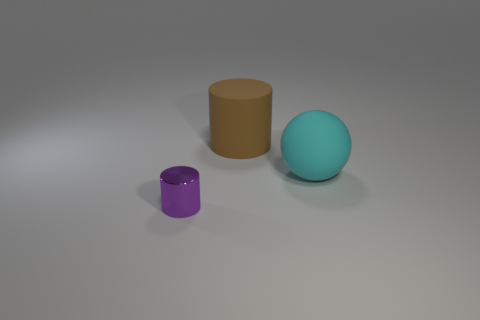Is there anything else that has the same material as the purple cylinder?
Offer a very short reply. No. There is a cylinder in front of the big cylinder; what is its material?
Make the answer very short. Metal. Is there a large thing that has the same shape as the tiny object?
Keep it short and to the point. Yes. What number of tiny green matte objects have the same shape as the tiny metallic thing?
Offer a very short reply. 0. There is a cylinder behind the small metal cylinder; is its size the same as the matte object that is in front of the brown rubber thing?
Your response must be concise. Yes. The large matte thing to the left of the object that is on the right side of the big rubber cylinder is what shape?
Offer a very short reply. Cylinder. Is the number of cylinders on the left side of the tiny object the same as the number of red matte balls?
Make the answer very short. Yes. There is a big object to the right of the cylinder that is behind the shiny cylinder that is on the left side of the large ball; what is it made of?
Give a very brief answer. Rubber. Is there another matte cylinder of the same size as the brown rubber cylinder?
Keep it short and to the point. No. What shape is the purple shiny thing?
Your response must be concise. Cylinder. 